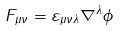<formula> <loc_0><loc_0><loc_500><loc_500>F _ { \mu \nu } = \varepsilon _ { \mu \nu \lambda } \nabla ^ { \lambda } \phi</formula> 